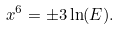Convert formula to latex. <formula><loc_0><loc_0><loc_500><loc_500>x ^ { 6 } = \pm 3 \ln ( E ) .</formula> 